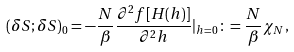<formula> <loc_0><loc_0><loc_500><loc_500>( \delta S ; \delta S ) _ { 0 } = - \frac { N } { \beta } \frac { \partial ^ { 2 } f [ H ( h ) ] } { \partial ^ { 2 } h } | _ { h = 0 } \colon = \frac { N } { \beta } \chi _ { N } ,</formula> 